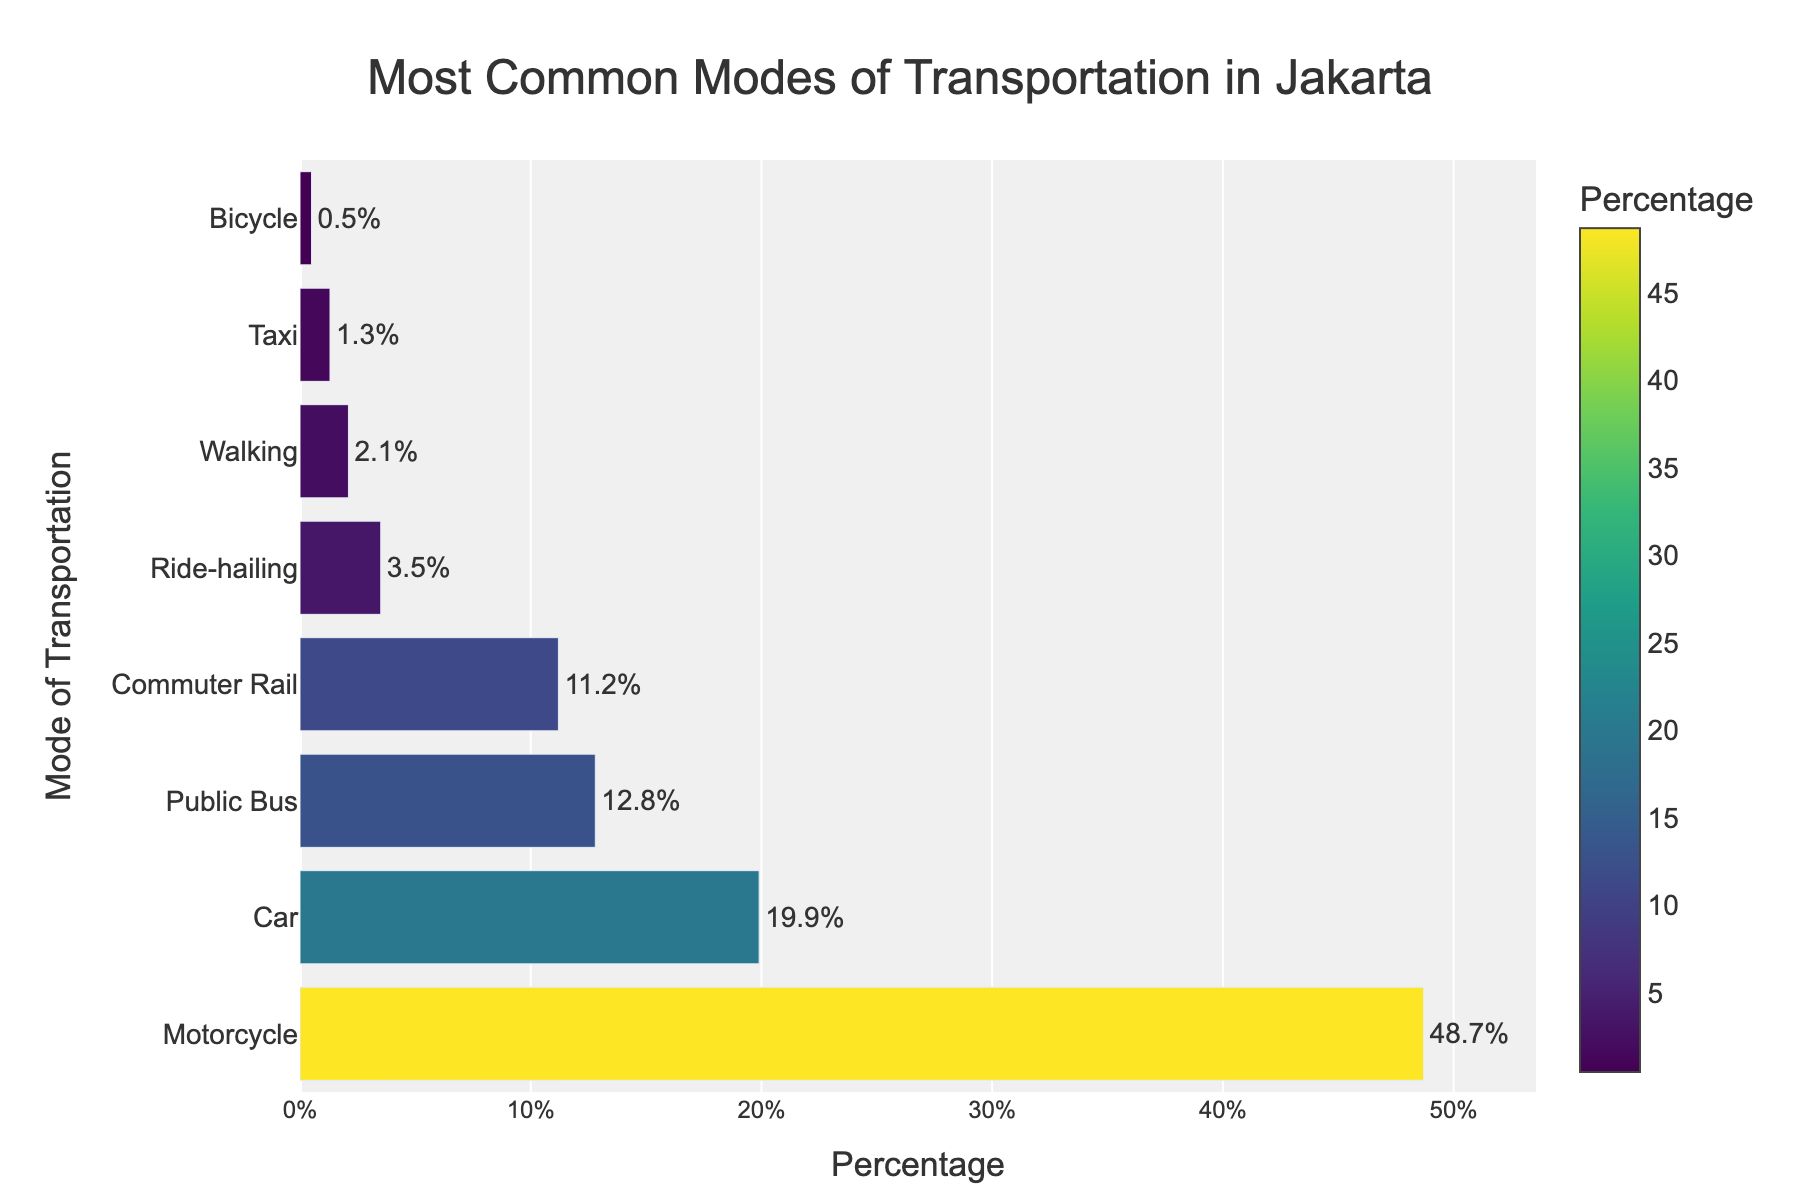What is the most common mode of transportation in Jakarta according to the chart? The chart shows bars representing different modes of transportation, with the motorcycle bar being the longest and having the highest percentage.
Answer: Motorcycle Which mode of transportation is used less frequently: Public Bus or Car? The chart indicates that the Public Bus usage percentage is 12.8% and Car usage percentage is 19.9%. Because 12.8% is less than 19.9%, Public Bus is used less frequently.
Answer: Public Bus What's the combined percentage usage of both Commuter Rail and Ride-hailing? According to the chart, the percentage usage of Commuter Rail is 11.2% and Ride-hailing is 3.5%. The combined percentage is calculated as 11.2% + 3.5% = 14.7%.
Answer: 14.7% Which mode has a higher usage percentage: Walking or Taxi? The chart shows that the usage percentage for Walking is 2.1% and for Taxi is 1.3%. Since 2.1% is greater than 1.3%, Walking has a higher usage percentage than Taxi.
Answer: Walking By how much does the usage of Motorcycles exceed the combined usage of Bicycle and Walking? The chart indicates that Motorcycle usage is 48.7%, Bicycle usage is 0.5%, and Walking usage is 2.1%. The combined usage of Bicycle and Walking is 0.5% + 2.1% = 2.6%. The difference is 48.7% - 2.6% = 46.1%.
Answer: 46.1% Which two modes of transportation have the closest usage percentages? Looking at the chart, the two closest percentages are Public Bus with 12.8% and Commuter Rail with 11.2%, with a difference of only 1.6%.
Answer: Public Bus and Commuter Rail What is the percentage difference between the usage of Motorcycles and Cars? According to the chart, Motorcycle usage is 48.7% and Car usage is 19.9%. The difference is calculated as 48.7% - 19.9% = 28.8%.
Answer: 28.8% Identify the fourth most common mode of transportation. The bar chart in descending order shows Motorcycle, Car, Public Bus, and then Commuter Rail, which makes Commuter Rail the fourth most common mode.
Answer: Commuter Rail Compare the visual lengths of the bars for Public Bus and Ride-hailing. Visually, the Public Bus bar is significantly longer than the Ride-hailing bar, indicating a higher usage percentage.
Answer: Public Bus is longer What is the median usage percentage among all the modes of transportation listed? To determine the median, list the percentages in ascending order: 0.5%, 1.3%, 2.1%, 3.5%, 11.2%, 12.8%, 19.9%, 48.7%. The median is the average of the middle two values (3.5% and 11.2%), which is (3.5 + 11.2) / 2 = 7.35%.
Answer: 7.35% 